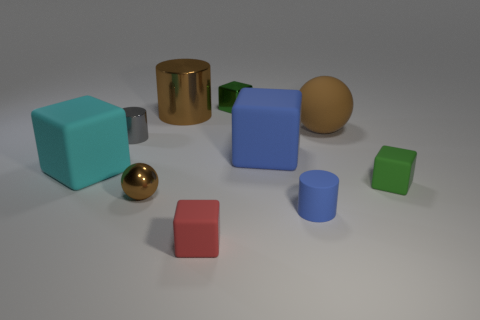Is the color of the tiny metal ball the same as the large metallic cylinder?
Offer a terse response. Yes. What material is the small red thing?
Ensure brevity in your answer.  Rubber. What is the size of the red block?
Offer a terse response. Small. There is a matte block that is both left of the big blue matte cube and behind the tiny blue matte cylinder; what size is it?
Make the answer very short. Large. There is a brown shiny object that is on the left side of the large metal object; what shape is it?
Keep it short and to the point. Sphere. Is the material of the big blue thing the same as the brown sphere that is behind the small green rubber object?
Give a very brief answer. Yes. Is the tiny green metallic object the same shape as the red object?
Your answer should be very brief. Yes. There is a blue object that is the same shape as the tiny red thing; what material is it?
Offer a very short reply. Rubber. There is a tiny block that is both behind the red block and in front of the shiny cube; what is its color?
Your answer should be very brief. Green. The small sphere has what color?
Your response must be concise. Brown. 